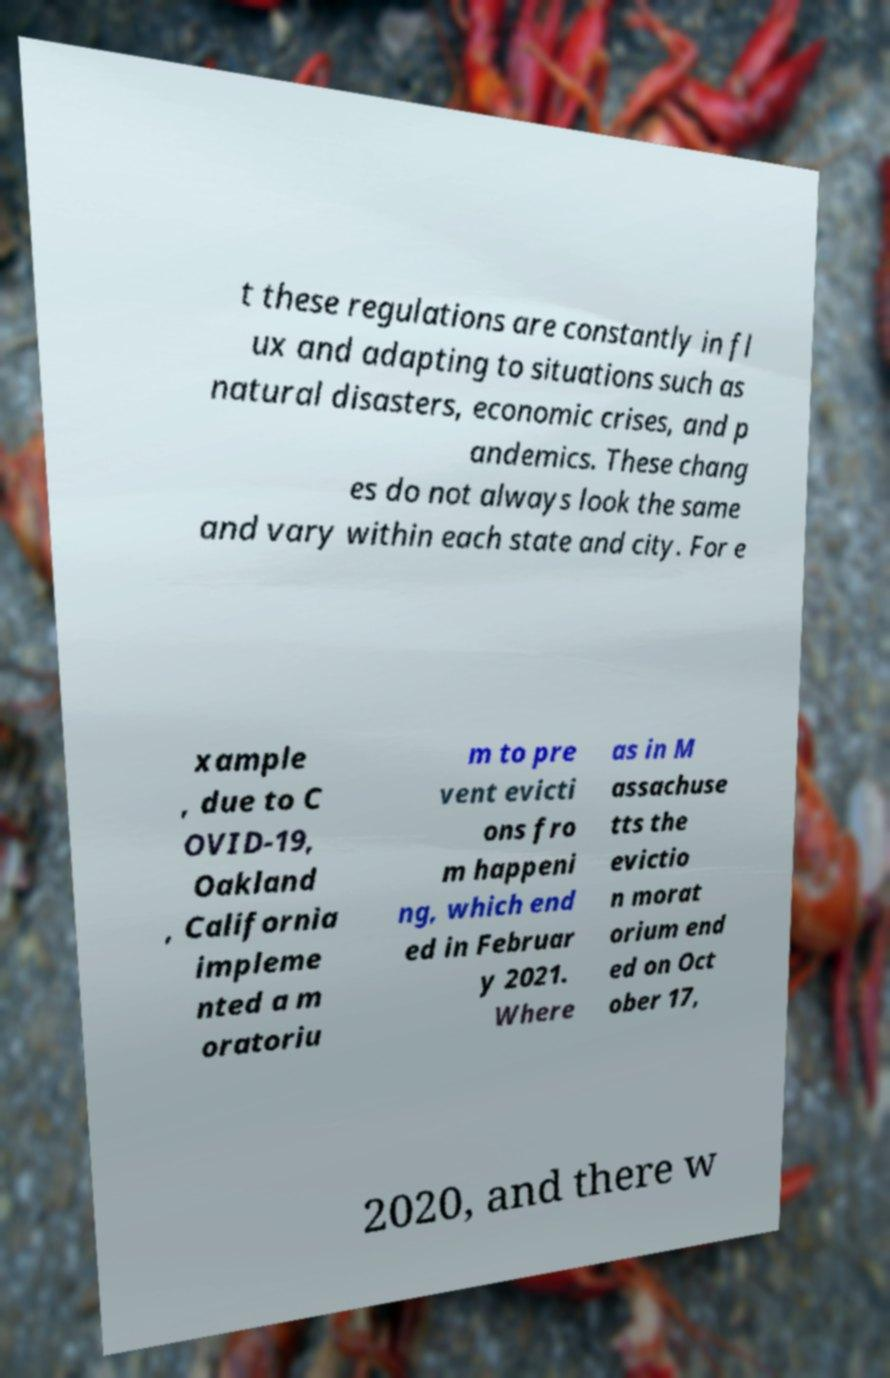For documentation purposes, I need the text within this image transcribed. Could you provide that? t these regulations are constantly in fl ux and adapting to situations such as natural disasters, economic crises, and p andemics. These chang es do not always look the same and vary within each state and city. For e xample , due to C OVID-19, Oakland , California impleme nted a m oratoriu m to pre vent evicti ons fro m happeni ng, which end ed in Februar y 2021. Where as in M assachuse tts the evictio n morat orium end ed on Oct ober 17, 2020, and there w 